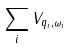<formula> <loc_0><loc_0><loc_500><loc_500>\sum _ { i } V _ { q _ { i } , \omega _ { i } }</formula> 